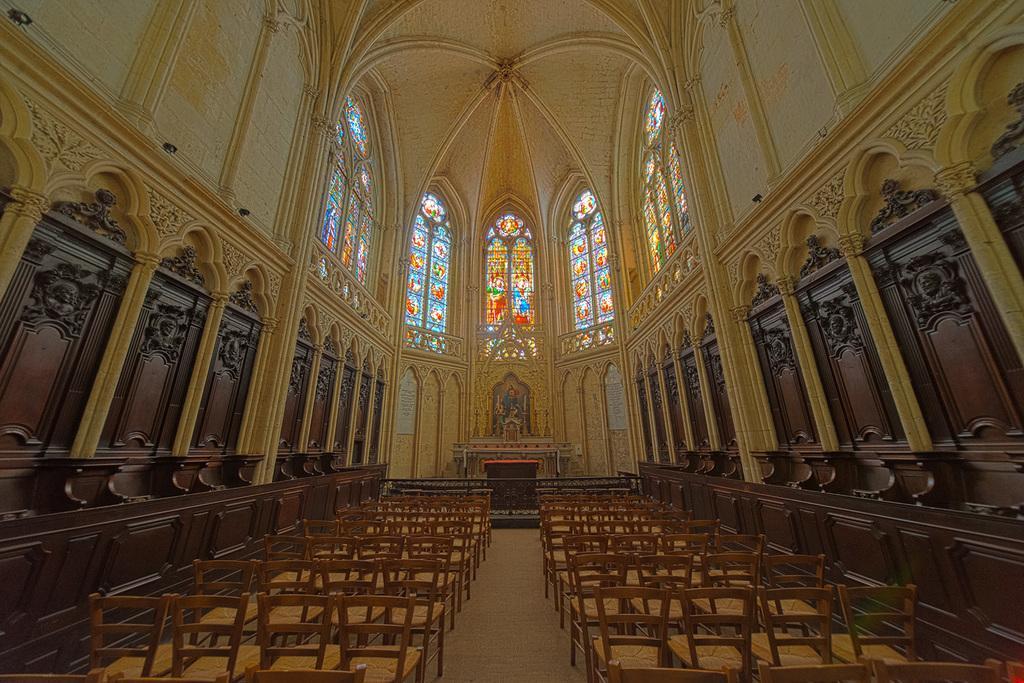Can you describe this image briefly? This picture is taken inside the room. In this image, on the right side, we can see some chairs. On the left side, we can see some chairs. On the right side, we can see a pillar. On the left side, we can also see a pillar. In the background, we can also see a glass window, sculptures. At the top, we can see a roof. 